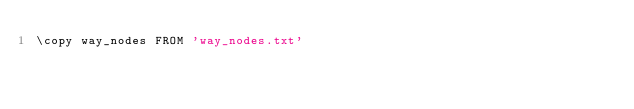Convert code to text. <code><loc_0><loc_0><loc_500><loc_500><_SQL_>\copy way_nodes FROM 'way_nodes.txt'</code> 